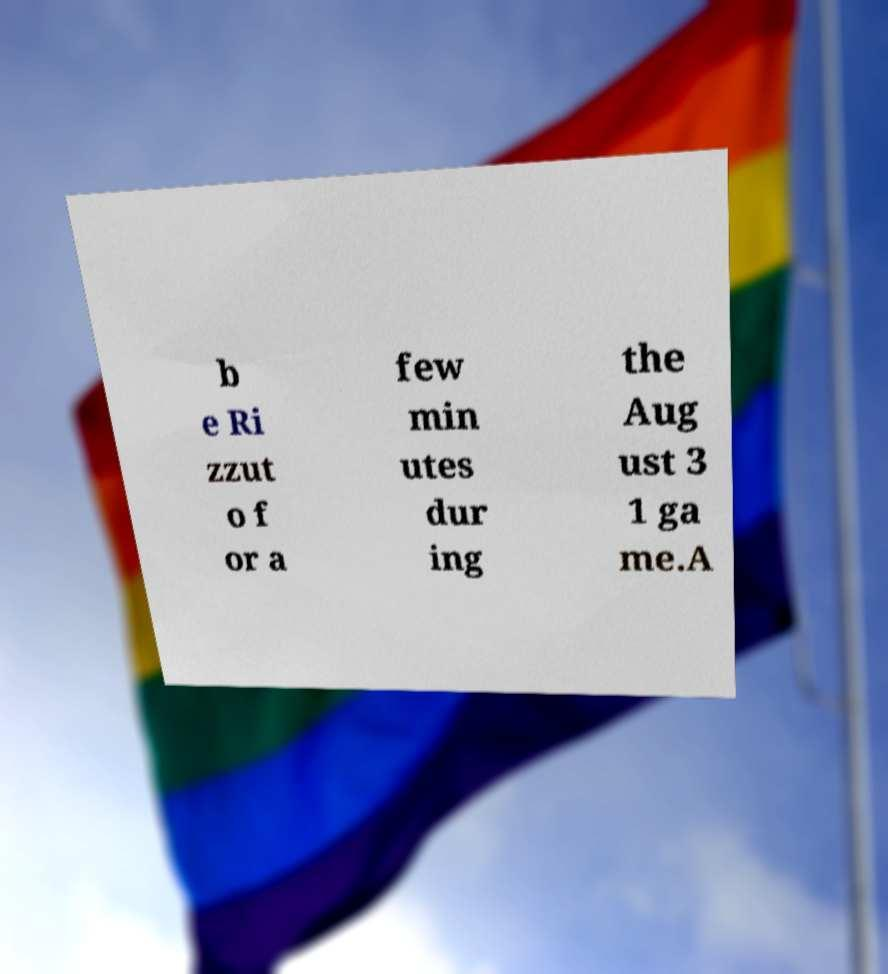Can you read and provide the text displayed in the image?This photo seems to have some interesting text. Can you extract and type it out for me? b e Ri zzut o f or a few min utes dur ing the Aug ust 3 1 ga me.A 